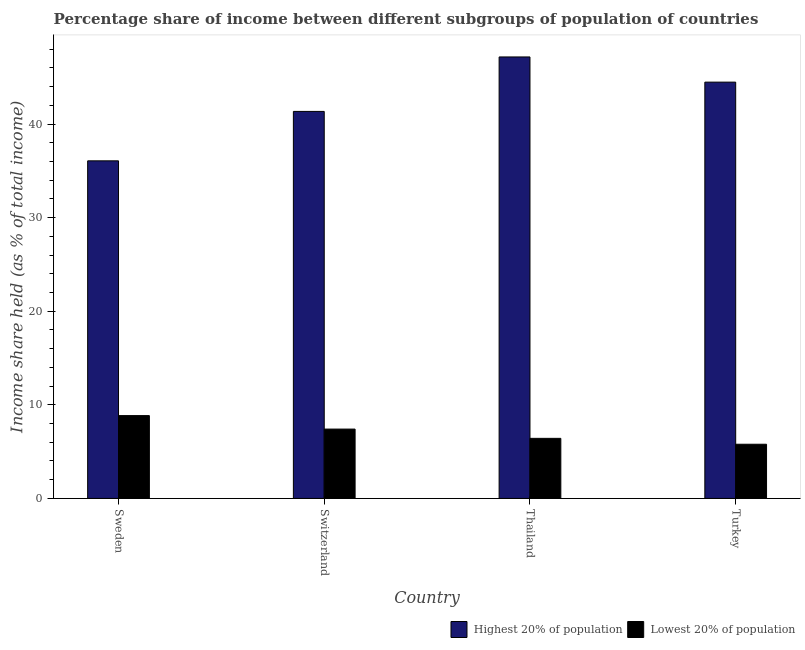How many different coloured bars are there?
Ensure brevity in your answer.  2. Are the number of bars on each tick of the X-axis equal?
Offer a terse response. Yes. How many bars are there on the 2nd tick from the right?
Your response must be concise. 2. In how many cases, is the number of bars for a given country not equal to the number of legend labels?
Provide a short and direct response. 0. What is the income share held by highest 20% of the population in Switzerland?
Make the answer very short. 41.35. Across all countries, what is the maximum income share held by lowest 20% of the population?
Offer a very short reply. 8.85. Across all countries, what is the minimum income share held by lowest 20% of the population?
Provide a succinct answer. 5.79. In which country was the income share held by highest 20% of the population maximum?
Ensure brevity in your answer.  Thailand. In which country was the income share held by lowest 20% of the population minimum?
Provide a succinct answer. Turkey. What is the total income share held by lowest 20% of the population in the graph?
Provide a short and direct response. 28.47. What is the difference between the income share held by lowest 20% of the population in Sweden and that in Switzerland?
Offer a very short reply. 1.44. What is the difference between the income share held by lowest 20% of the population in Sweden and the income share held by highest 20% of the population in Turkey?
Keep it short and to the point. -35.63. What is the average income share held by highest 20% of the population per country?
Offer a terse response. 42.27. What is the difference between the income share held by lowest 20% of the population and income share held by highest 20% of the population in Thailand?
Give a very brief answer. -40.75. In how many countries, is the income share held by highest 20% of the population greater than 16 %?
Ensure brevity in your answer.  4. What is the ratio of the income share held by highest 20% of the population in Switzerland to that in Thailand?
Provide a short and direct response. 0.88. What is the difference between the highest and the second highest income share held by lowest 20% of the population?
Keep it short and to the point. 1.44. What is the difference between the highest and the lowest income share held by highest 20% of the population?
Give a very brief answer. 11.1. In how many countries, is the income share held by highest 20% of the population greater than the average income share held by highest 20% of the population taken over all countries?
Provide a short and direct response. 2. What does the 1st bar from the left in Sweden represents?
Make the answer very short. Highest 20% of population. What does the 1st bar from the right in Thailand represents?
Offer a terse response. Lowest 20% of population. How many bars are there?
Your answer should be compact. 8. What is the difference between two consecutive major ticks on the Y-axis?
Offer a terse response. 10. Does the graph contain grids?
Make the answer very short. No. Where does the legend appear in the graph?
Your response must be concise. Bottom right. How are the legend labels stacked?
Provide a succinct answer. Horizontal. What is the title of the graph?
Provide a short and direct response. Percentage share of income between different subgroups of population of countries. What is the label or title of the X-axis?
Offer a terse response. Country. What is the label or title of the Y-axis?
Keep it short and to the point. Income share held (as % of total income). What is the Income share held (as % of total income) of Highest 20% of population in Sweden?
Your response must be concise. 36.07. What is the Income share held (as % of total income) in Lowest 20% of population in Sweden?
Make the answer very short. 8.85. What is the Income share held (as % of total income) in Highest 20% of population in Switzerland?
Make the answer very short. 41.35. What is the Income share held (as % of total income) in Lowest 20% of population in Switzerland?
Offer a very short reply. 7.41. What is the Income share held (as % of total income) in Highest 20% of population in Thailand?
Your answer should be very brief. 47.17. What is the Income share held (as % of total income) in Lowest 20% of population in Thailand?
Offer a terse response. 6.42. What is the Income share held (as % of total income) of Highest 20% of population in Turkey?
Give a very brief answer. 44.48. What is the Income share held (as % of total income) of Lowest 20% of population in Turkey?
Offer a terse response. 5.79. Across all countries, what is the maximum Income share held (as % of total income) of Highest 20% of population?
Offer a very short reply. 47.17. Across all countries, what is the maximum Income share held (as % of total income) in Lowest 20% of population?
Your answer should be compact. 8.85. Across all countries, what is the minimum Income share held (as % of total income) in Highest 20% of population?
Offer a terse response. 36.07. Across all countries, what is the minimum Income share held (as % of total income) of Lowest 20% of population?
Your response must be concise. 5.79. What is the total Income share held (as % of total income) of Highest 20% of population in the graph?
Offer a terse response. 169.07. What is the total Income share held (as % of total income) in Lowest 20% of population in the graph?
Make the answer very short. 28.47. What is the difference between the Income share held (as % of total income) in Highest 20% of population in Sweden and that in Switzerland?
Your answer should be very brief. -5.28. What is the difference between the Income share held (as % of total income) of Lowest 20% of population in Sweden and that in Switzerland?
Your answer should be compact. 1.44. What is the difference between the Income share held (as % of total income) of Highest 20% of population in Sweden and that in Thailand?
Your answer should be compact. -11.1. What is the difference between the Income share held (as % of total income) in Lowest 20% of population in Sweden and that in Thailand?
Offer a very short reply. 2.43. What is the difference between the Income share held (as % of total income) of Highest 20% of population in Sweden and that in Turkey?
Your answer should be compact. -8.41. What is the difference between the Income share held (as % of total income) in Lowest 20% of population in Sweden and that in Turkey?
Ensure brevity in your answer.  3.06. What is the difference between the Income share held (as % of total income) of Highest 20% of population in Switzerland and that in Thailand?
Offer a terse response. -5.82. What is the difference between the Income share held (as % of total income) in Lowest 20% of population in Switzerland and that in Thailand?
Your answer should be compact. 0.99. What is the difference between the Income share held (as % of total income) of Highest 20% of population in Switzerland and that in Turkey?
Your answer should be compact. -3.13. What is the difference between the Income share held (as % of total income) in Lowest 20% of population in Switzerland and that in Turkey?
Provide a short and direct response. 1.62. What is the difference between the Income share held (as % of total income) of Highest 20% of population in Thailand and that in Turkey?
Ensure brevity in your answer.  2.69. What is the difference between the Income share held (as % of total income) of Lowest 20% of population in Thailand and that in Turkey?
Offer a very short reply. 0.63. What is the difference between the Income share held (as % of total income) in Highest 20% of population in Sweden and the Income share held (as % of total income) in Lowest 20% of population in Switzerland?
Provide a short and direct response. 28.66. What is the difference between the Income share held (as % of total income) in Highest 20% of population in Sweden and the Income share held (as % of total income) in Lowest 20% of population in Thailand?
Your answer should be very brief. 29.65. What is the difference between the Income share held (as % of total income) in Highest 20% of population in Sweden and the Income share held (as % of total income) in Lowest 20% of population in Turkey?
Your response must be concise. 30.28. What is the difference between the Income share held (as % of total income) of Highest 20% of population in Switzerland and the Income share held (as % of total income) of Lowest 20% of population in Thailand?
Your answer should be very brief. 34.93. What is the difference between the Income share held (as % of total income) of Highest 20% of population in Switzerland and the Income share held (as % of total income) of Lowest 20% of population in Turkey?
Your answer should be very brief. 35.56. What is the difference between the Income share held (as % of total income) of Highest 20% of population in Thailand and the Income share held (as % of total income) of Lowest 20% of population in Turkey?
Offer a very short reply. 41.38. What is the average Income share held (as % of total income) in Highest 20% of population per country?
Make the answer very short. 42.27. What is the average Income share held (as % of total income) in Lowest 20% of population per country?
Make the answer very short. 7.12. What is the difference between the Income share held (as % of total income) in Highest 20% of population and Income share held (as % of total income) in Lowest 20% of population in Sweden?
Your response must be concise. 27.22. What is the difference between the Income share held (as % of total income) of Highest 20% of population and Income share held (as % of total income) of Lowest 20% of population in Switzerland?
Make the answer very short. 33.94. What is the difference between the Income share held (as % of total income) in Highest 20% of population and Income share held (as % of total income) in Lowest 20% of population in Thailand?
Provide a succinct answer. 40.75. What is the difference between the Income share held (as % of total income) of Highest 20% of population and Income share held (as % of total income) of Lowest 20% of population in Turkey?
Make the answer very short. 38.69. What is the ratio of the Income share held (as % of total income) of Highest 20% of population in Sweden to that in Switzerland?
Make the answer very short. 0.87. What is the ratio of the Income share held (as % of total income) of Lowest 20% of population in Sweden to that in Switzerland?
Give a very brief answer. 1.19. What is the ratio of the Income share held (as % of total income) in Highest 20% of population in Sweden to that in Thailand?
Offer a terse response. 0.76. What is the ratio of the Income share held (as % of total income) in Lowest 20% of population in Sweden to that in Thailand?
Your answer should be very brief. 1.38. What is the ratio of the Income share held (as % of total income) of Highest 20% of population in Sweden to that in Turkey?
Make the answer very short. 0.81. What is the ratio of the Income share held (as % of total income) in Lowest 20% of population in Sweden to that in Turkey?
Offer a terse response. 1.53. What is the ratio of the Income share held (as % of total income) of Highest 20% of population in Switzerland to that in Thailand?
Your answer should be very brief. 0.88. What is the ratio of the Income share held (as % of total income) in Lowest 20% of population in Switzerland to that in Thailand?
Your answer should be very brief. 1.15. What is the ratio of the Income share held (as % of total income) of Highest 20% of population in Switzerland to that in Turkey?
Provide a short and direct response. 0.93. What is the ratio of the Income share held (as % of total income) in Lowest 20% of population in Switzerland to that in Turkey?
Keep it short and to the point. 1.28. What is the ratio of the Income share held (as % of total income) in Highest 20% of population in Thailand to that in Turkey?
Ensure brevity in your answer.  1.06. What is the ratio of the Income share held (as % of total income) of Lowest 20% of population in Thailand to that in Turkey?
Provide a short and direct response. 1.11. What is the difference between the highest and the second highest Income share held (as % of total income) of Highest 20% of population?
Ensure brevity in your answer.  2.69. What is the difference between the highest and the second highest Income share held (as % of total income) of Lowest 20% of population?
Give a very brief answer. 1.44. What is the difference between the highest and the lowest Income share held (as % of total income) of Highest 20% of population?
Provide a short and direct response. 11.1. What is the difference between the highest and the lowest Income share held (as % of total income) in Lowest 20% of population?
Offer a terse response. 3.06. 